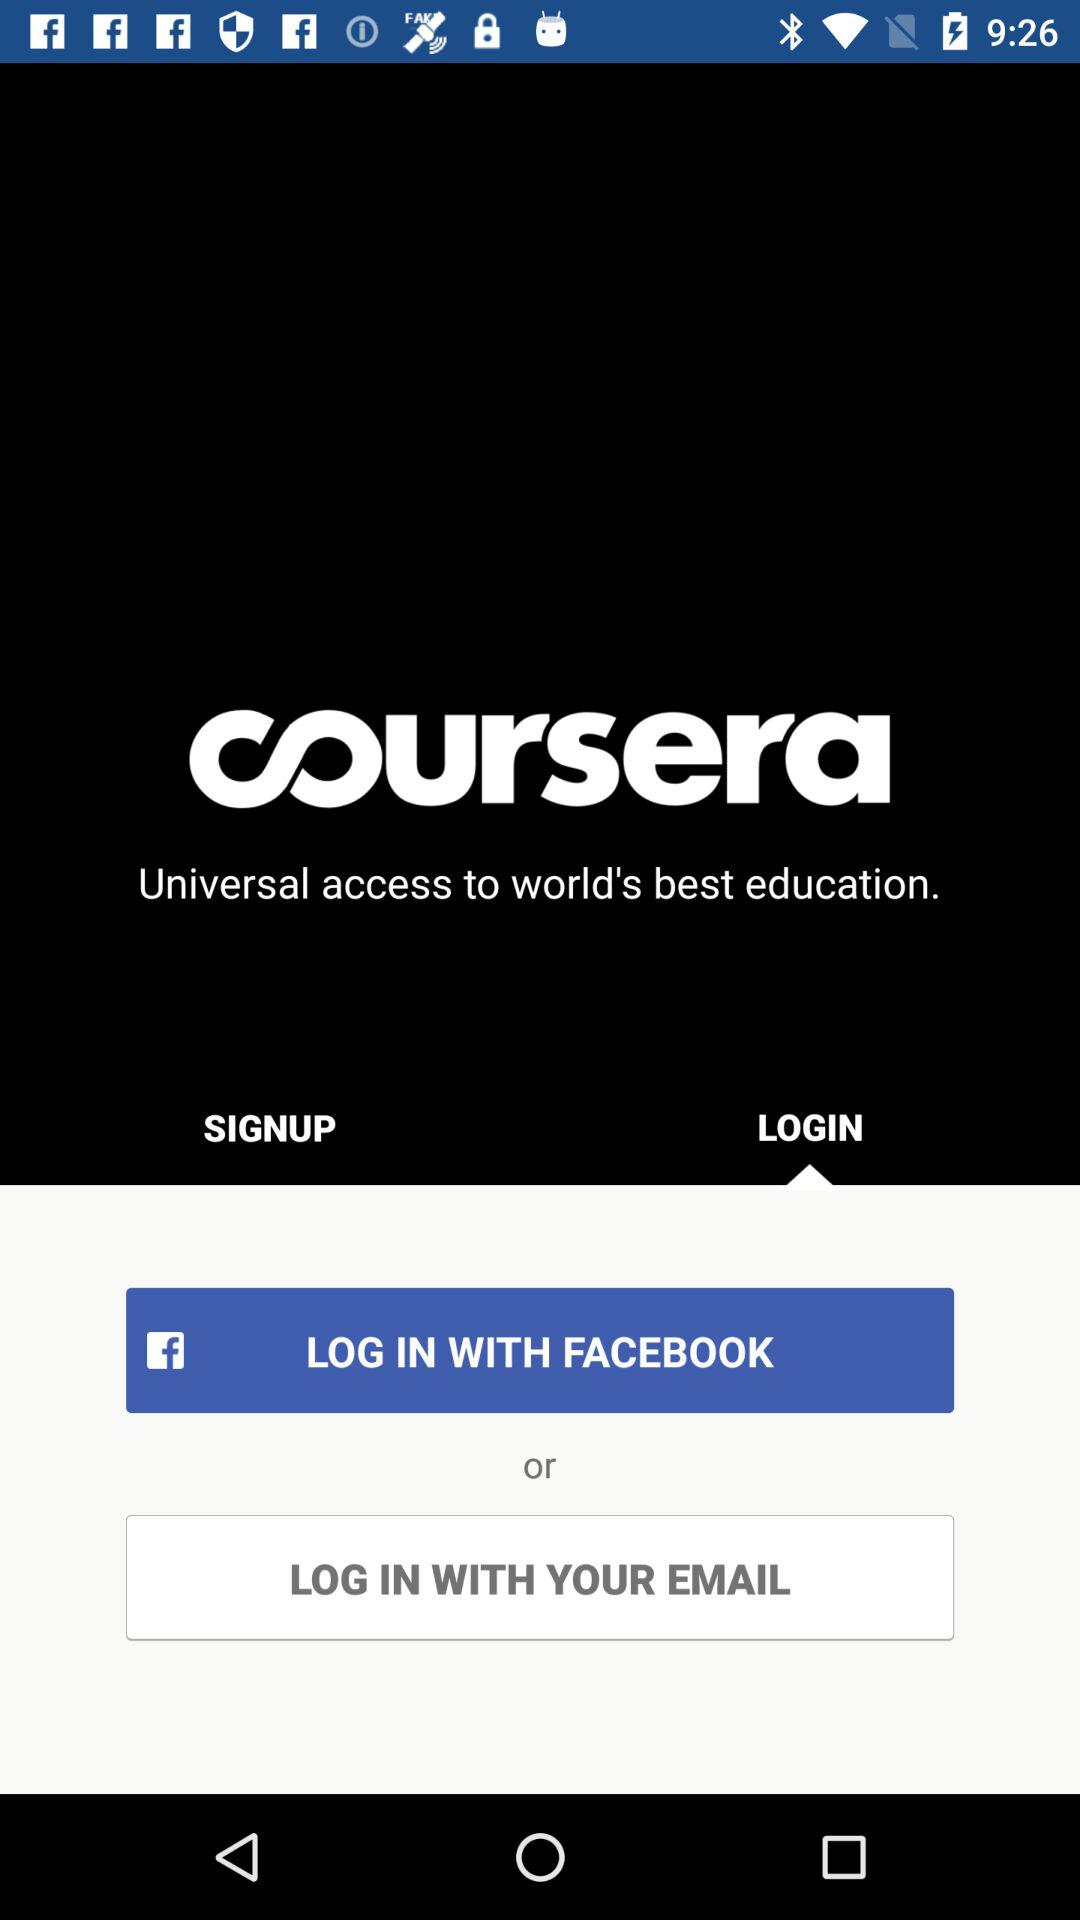Which option has been selected? The option that has been selected is "LOGIN". 